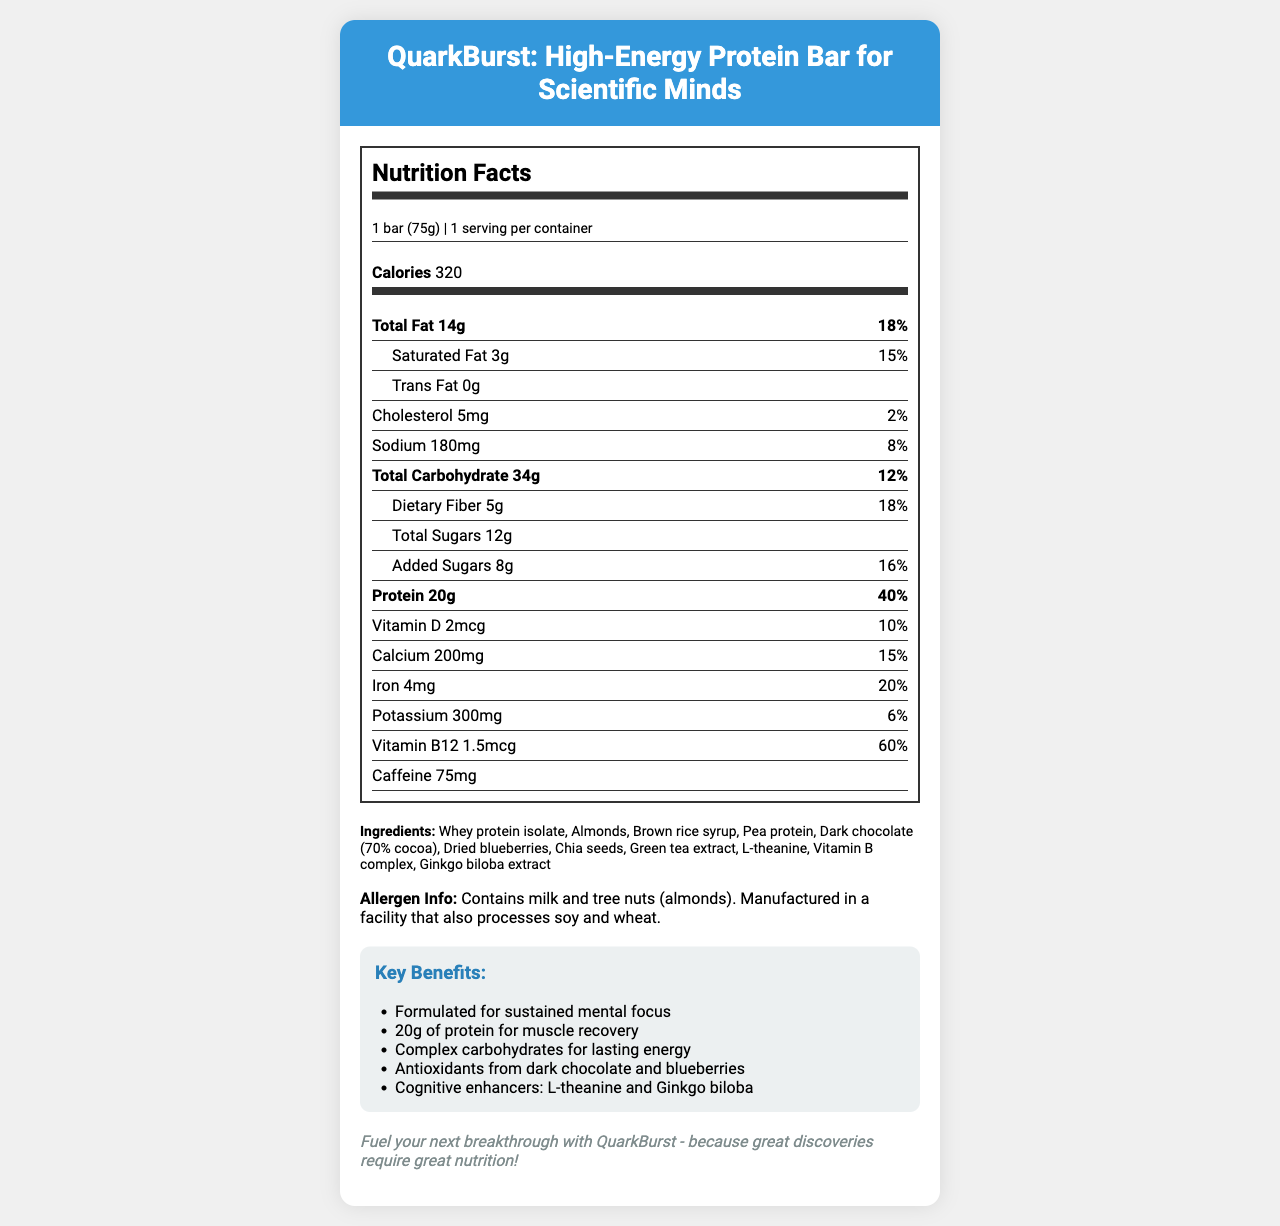what is the serving size? The serving size is explicitly mentioned in the document under the "Nutrition Facts" section.
Answer: 1 bar (75g) how many calories are there per serving? The document states the calories per serving in the "Nutrition Facts" section.
Answer: 320 what is the amount of protein per serving? The amount of protein per serving is clearly noted in the "Nutrition Facts" section.
Answer: 20g what ingredients are used in this protein bar? The ingredients list is provided in the "Ingredients" section of the document.
Answer: Whey protein isolate, Almonds, Brown rice syrup, Pea protein, Dark chocolate (70% cocoa), Dried blueberries, Chia seeds, Green tea extract, L-theanine, Vitamin B complex, Ginkgo biloba extract what is the daily value percentage for iron? The daily value percentage for iron can be found under the "Iron" section in the "Nutrition Facts."
Answer: 20% how many grams of dietary fiber does the bar contain? The amount of dietary fiber per serving is listed under the "Dietary Fiber" section in the "Nutrition Facts."
Answer: 5g how much caffeine is in the bar? A. 50mg B. 75mg C. 100mg D. 0mg The amount of caffeine in the bar is noted as 75mg in the "Nutrition Facts."
Answer: B. 75mg which of the following statements is a marketing claim made for the QuarkBurst bar? A. Contains Omega-3s B. Sustained mental focus C. Organic ingredients only D. Zero calories The claim of "Formulated for sustained mental focus" is listed under the "Key Benefits" section of the document.
Answer: B. Sustained mental focus does the product contain any trans fat? The document clearly states that the amount of trans fat is 0g.
Answer: No summarize the main idea of this nutrition facts label The document lays out the nutritional content, ingredients, allergen info, and key benefits of the QuarkBurst bar while stressing its suitability for sustained mental focus and long research sessions.
Answer: QuarkBurst is a high-energy protein bar designed specifically for scientific minds needing lasting energy and mental focus during long research sessions. It contains 320 calories per serving, with significant amounts of protein, complex carbohydrates, fiber, and various vitamins and minerals. Additionally, it is formulated with cognitive enhancers and antioxidants. what is the exact formulation of the dark chocolate used in the ingredients? The document only mentions "Dark chocolate (70% cocoa)" but does not provide the exact formulation beyond that.
Answer: Not enough information how much Vitamin B12 does one serving of QuarkBurst provide? The amount of Vitamin B12 per serving is explicitly stated in the "Nutrition Facts" section.
Answer: 1.5mcg what health benefit does QuarkBurst claim to offer regarding antioxidants? The health benefits related to antioxidants are described in the "Key Benefits" section, mentioning dark chocolate and blueberries as sources.
Answer: Antioxidants from dark chocolate and blueberries how many added sugars are in the bar? A. 5g B. 12g C. 8g D. 0g The amount of added sugars per serving is listed as 8g in the "Nutrition Facts," making option C correct.
Answer: C. 8g are there any nuts in the QuarkBurst bar? The ingredients list includes almonds, and the allergen info mentions tree nuts (almonds) as part of the composition.
Answer: Yes 